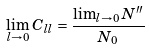<formula> <loc_0><loc_0><loc_500><loc_500>\lim _ { l \rightarrow 0 } C _ { l l } = \frac { \lim _ { l \rightarrow 0 } N ^ { \prime \prime } } { N _ { 0 } }</formula> 